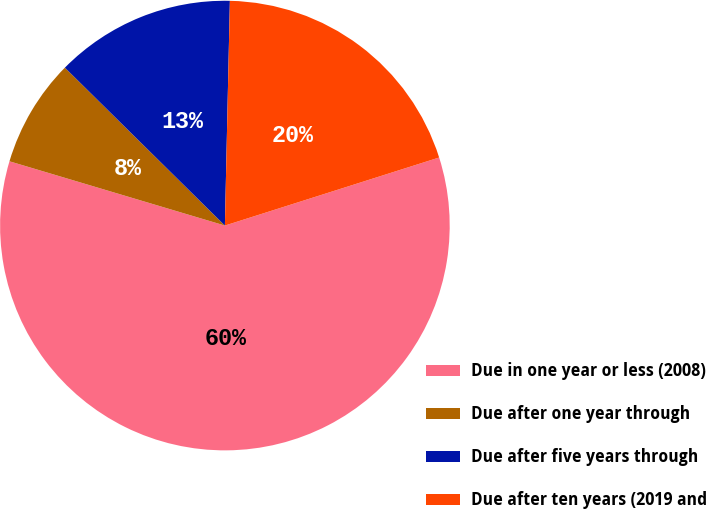Convert chart to OTSL. <chart><loc_0><loc_0><loc_500><loc_500><pie_chart><fcel>Due in one year or less (2008)<fcel>Due after one year through<fcel>Due after five years through<fcel>Due after ten years (2019 and<nl><fcel>59.51%<fcel>7.78%<fcel>12.96%<fcel>19.75%<nl></chart> 